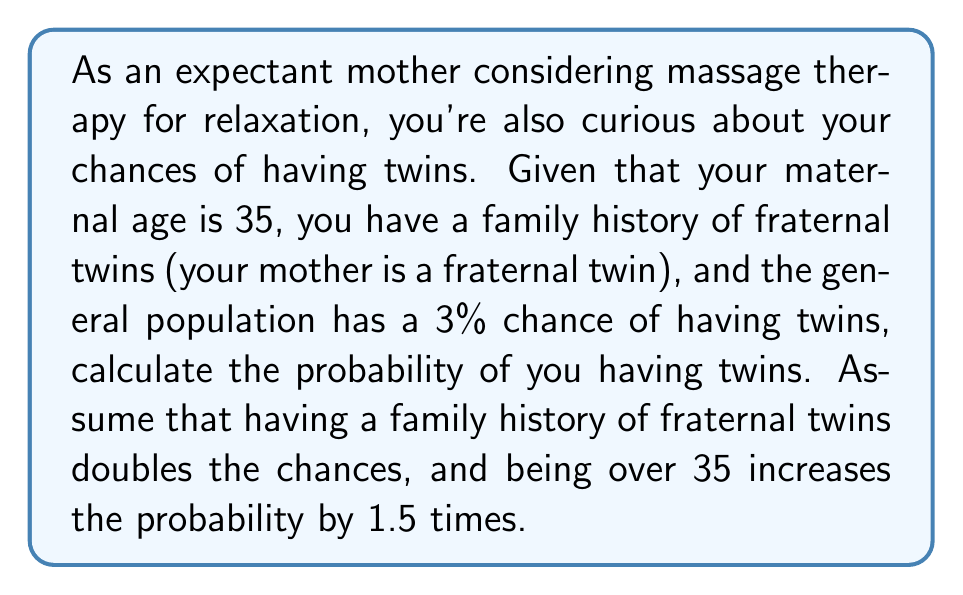Can you answer this question? Let's approach this step-by-step:

1) Start with the base probability of twins in the general population:
   $P(\text{twins})_{\text{base}} = 0.03$ or 3%

2) Account for family history of fraternal twins:
   $P(\text{twins})_{\text{family}} = 2 \times P(\text{twins})_{\text{base}}$
   $P(\text{twins})_{\text{family}} = 2 \times 0.03 = 0.06$ or 6%

3) Account for maternal age over 35:
   $P(\text{twins})_{\text{final}} = 1.5 \times P(\text{twins})_{\text{family}}$
   $P(\text{twins})_{\text{final}} = 1.5 \times 0.06 = 0.09$ or 9%

Therefore, the probability of having twins given your family history and maternal age is 0.09 or 9%.

To express this as odds:
$\text{Odds} = \frac{P(\text{event})}{1 - P(\text{event})} = \frac{0.09}{1 - 0.09} = \frac{0.09}{0.91} \approx 0.0989$

This can be expressed as approximately 1:10 odds.
Answer: 9% probability or approximately 1:10 odds 